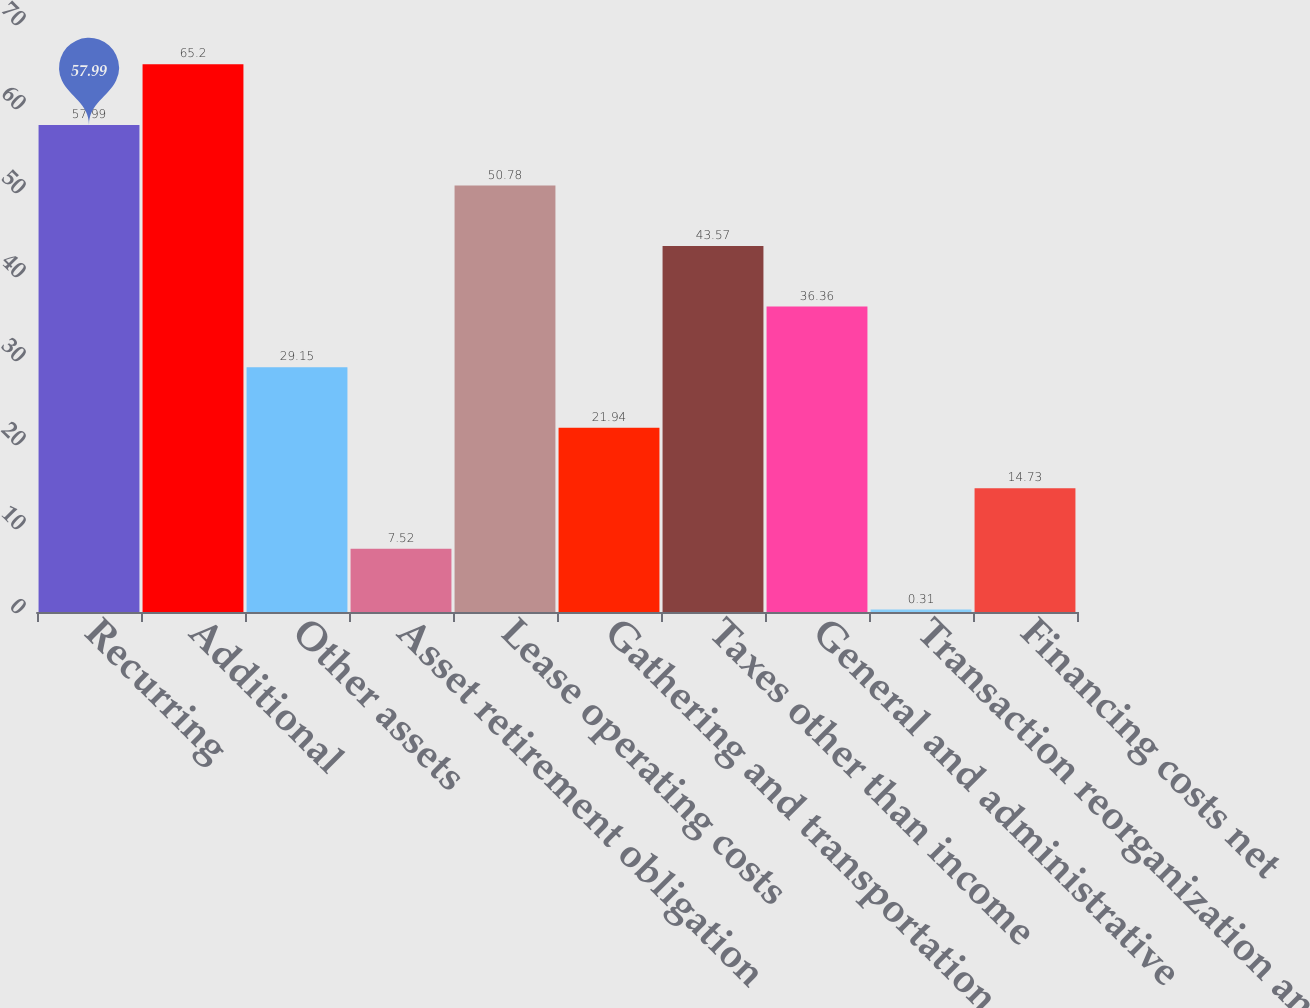Convert chart to OTSL. <chart><loc_0><loc_0><loc_500><loc_500><bar_chart><fcel>Recurring<fcel>Additional<fcel>Other assets<fcel>Asset retirement obligation<fcel>Lease operating costs<fcel>Gathering and transportation<fcel>Taxes other than income<fcel>General and administrative<fcel>Transaction reorganization and<fcel>Financing costs net<nl><fcel>57.99<fcel>65.2<fcel>29.15<fcel>7.52<fcel>50.78<fcel>21.94<fcel>43.57<fcel>36.36<fcel>0.31<fcel>14.73<nl></chart> 